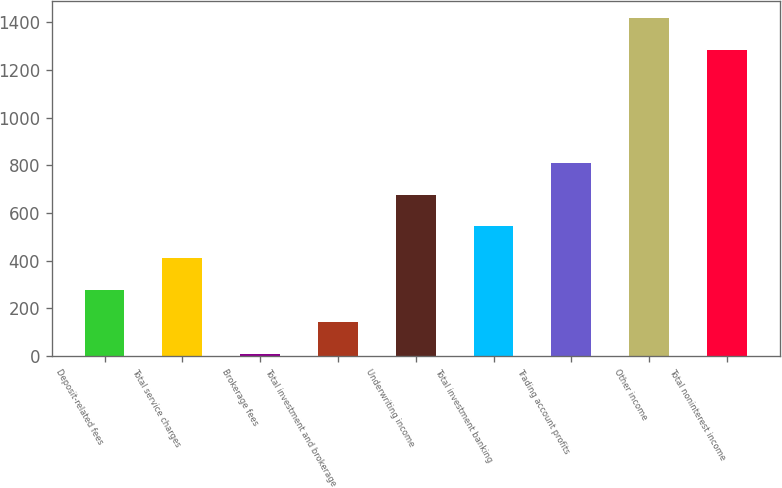<chart> <loc_0><loc_0><loc_500><loc_500><bar_chart><fcel>Deposit-related fees<fcel>Total service charges<fcel>Brokerage fees<fcel>Total investment and brokerage<fcel>Underwriting income<fcel>Total investment banking<fcel>Trading account profits<fcel>Other income<fcel>Total noninterest income<nl><fcel>275.6<fcel>409.4<fcel>8<fcel>141.8<fcel>677<fcel>543.2<fcel>810.8<fcel>1417.8<fcel>1284<nl></chart> 